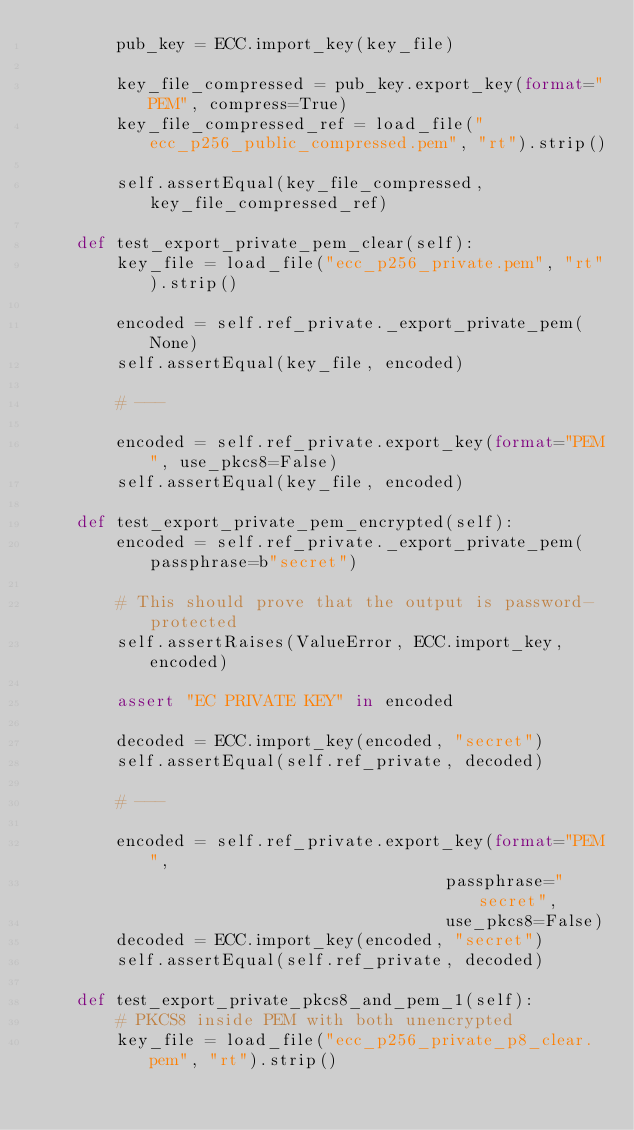Convert code to text. <code><loc_0><loc_0><loc_500><loc_500><_Python_>        pub_key = ECC.import_key(key_file)

        key_file_compressed = pub_key.export_key(format="PEM", compress=True)
        key_file_compressed_ref = load_file("ecc_p256_public_compressed.pem", "rt").strip()

        self.assertEqual(key_file_compressed, key_file_compressed_ref)

    def test_export_private_pem_clear(self):
        key_file = load_file("ecc_p256_private.pem", "rt").strip()

        encoded = self.ref_private._export_private_pem(None)
        self.assertEqual(key_file, encoded)

        # ---

        encoded = self.ref_private.export_key(format="PEM", use_pkcs8=False)
        self.assertEqual(key_file, encoded)

    def test_export_private_pem_encrypted(self):
        encoded = self.ref_private._export_private_pem(passphrase=b"secret")

        # This should prove that the output is password-protected
        self.assertRaises(ValueError, ECC.import_key, encoded)

        assert "EC PRIVATE KEY" in encoded

        decoded = ECC.import_key(encoded, "secret")
        self.assertEqual(self.ref_private, decoded)

        # ---

        encoded = self.ref_private.export_key(format="PEM",
                                         passphrase="secret",
                                         use_pkcs8=False)
        decoded = ECC.import_key(encoded, "secret")
        self.assertEqual(self.ref_private, decoded)

    def test_export_private_pkcs8_and_pem_1(self):
        # PKCS8 inside PEM with both unencrypted
        key_file = load_file("ecc_p256_private_p8_clear.pem", "rt").strip()
</code> 